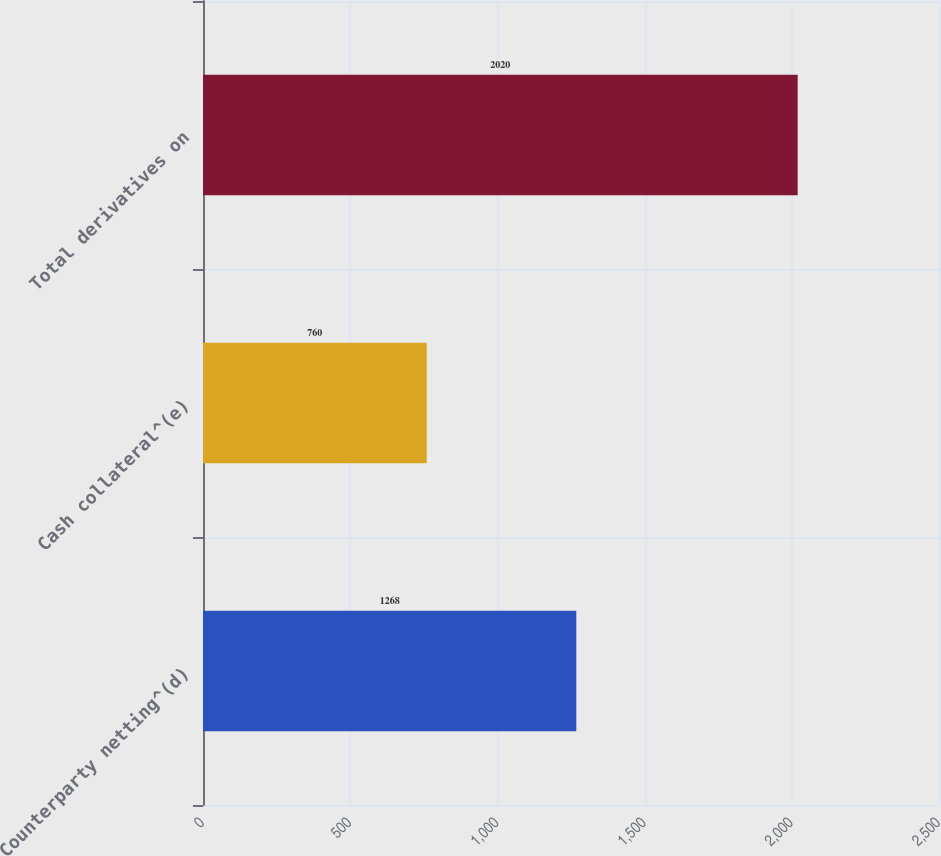Convert chart. <chart><loc_0><loc_0><loc_500><loc_500><bar_chart><fcel>Counterparty netting^(d)<fcel>Cash collateral^(e)<fcel>Total derivatives on<nl><fcel>1268<fcel>760<fcel>2020<nl></chart> 